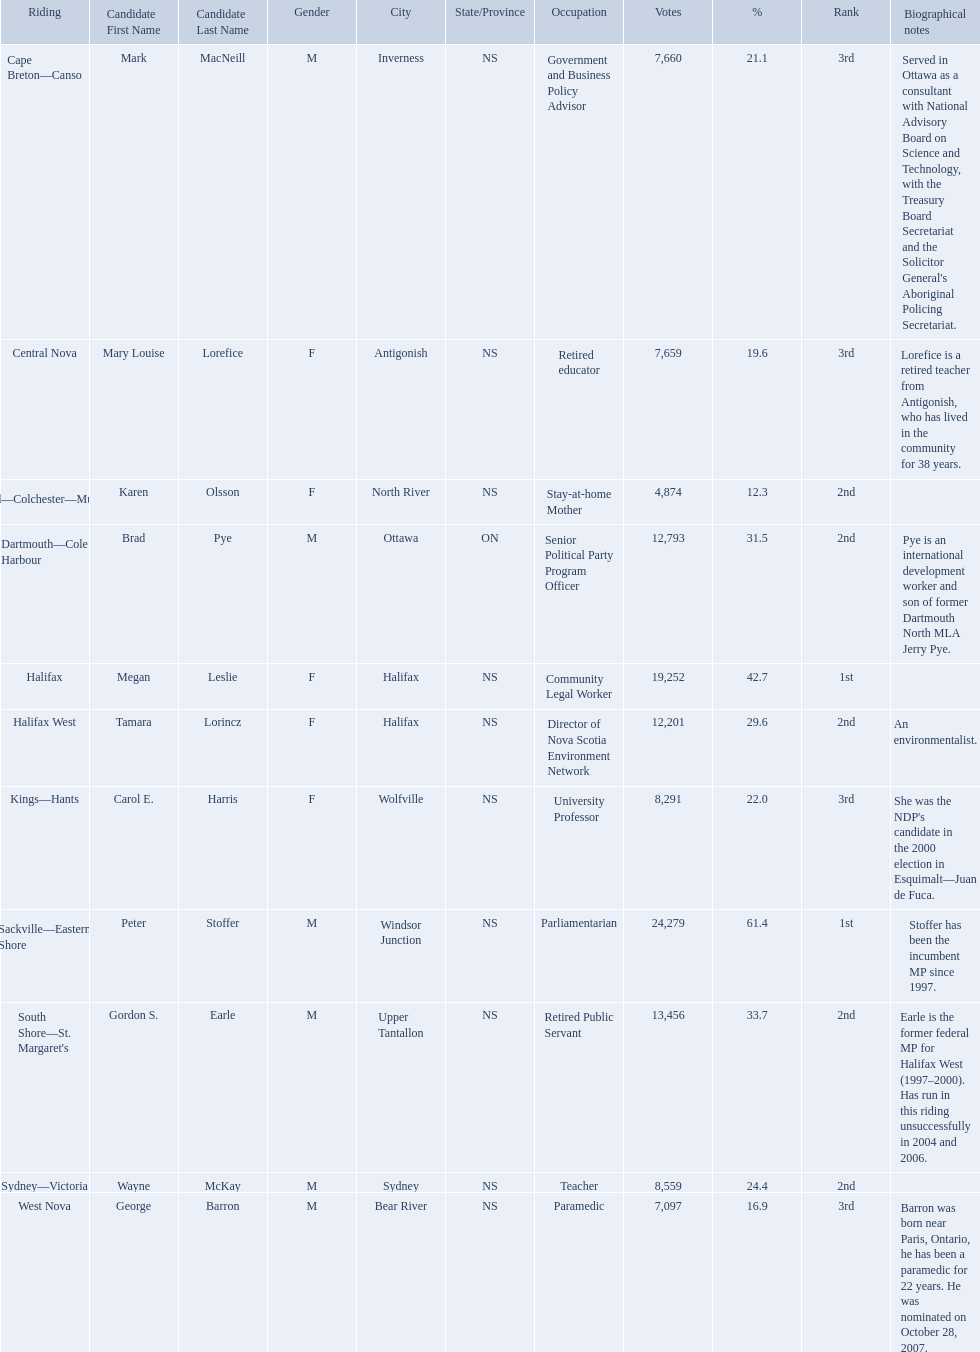Who were the new democratic party candidates, 2008? Mark MacNeill, Mary Louise Lorefice, Karen Olsson, Brad Pye, Megan Leslie, Tamara Lorincz, Carol E. Harris, Peter Stoffer, Gordon S. Earle, Wayne McKay, George Barron. Who had the 2nd highest number of votes? Megan Leslie, Peter Stoffer. How many votes did she receive? 19,252. 